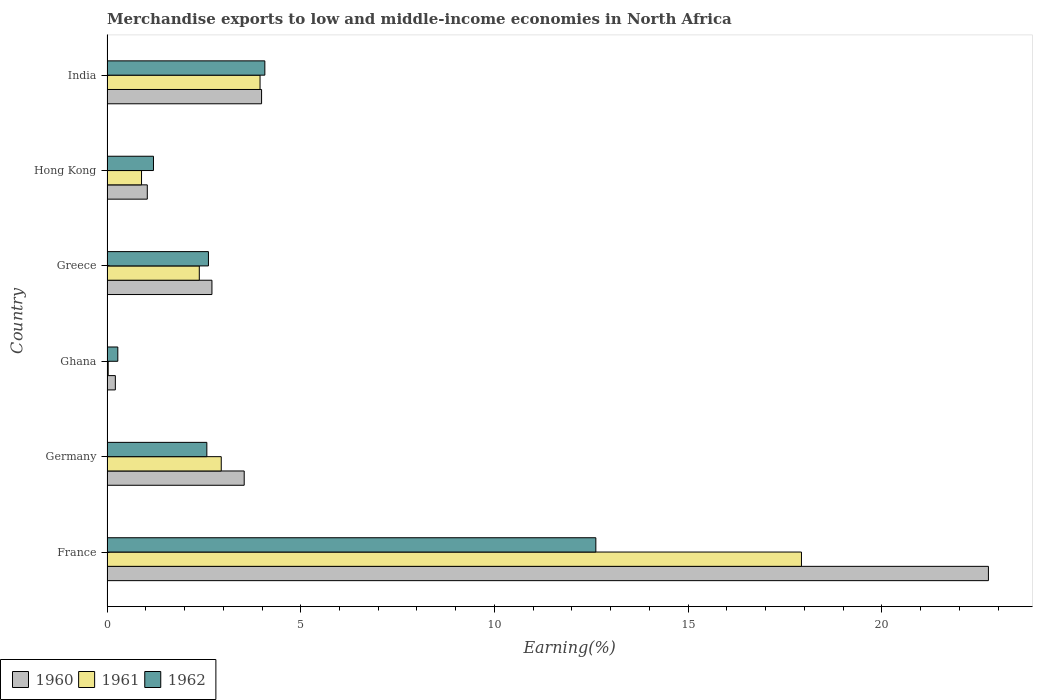How many different coloured bars are there?
Keep it short and to the point. 3. Are the number of bars on each tick of the Y-axis equal?
Your answer should be very brief. Yes. How many bars are there on the 1st tick from the top?
Give a very brief answer. 3. In how many cases, is the number of bars for a given country not equal to the number of legend labels?
Offer a very short reply. 0. What is the percentage of amount earned from merchandise exports in 1960 in Ghana?
Offer a very short reply. 0.22. Across all countries, what is the maximum percentage of amount earned from merchandise exports in 1962?
Ensure brevity in your answer.  12.62. Across all countries, what is the minimum percentage of amount earned from merchandise exports in 1960?
Provide a succinct answer. 0.22. What is the total percentage of amount earned from merchandise exports in 1960 in the graph?
Give a very brief answer. 34.24. What is the difference between the percentage of amount earned from merchandise exports in 1960 in France and that in Greece?
Keep it short and to the point. 20.04. What is the difference between the percentage of amount earned from merchandise exports in 1960 in Hong Kong and the percentage of amount earned from merchandise exports in 1962 in France?
Provide a succinct answer. -11.58. What is the average percentage of amount earned from merchandise exports in 1962 per country?
Your answer should be compact. 3.89. What is the difference between the percentage of amount earned from merchandise exports in 1961 and percentage of amount earned from merchandise exports in 1960 in France?
Give a very brief answer. -4.83. What is the ratio of the percentage of amount earned from merchandise exports in 1960 in Germany to that in Greece?
Keep it short and to the point. 1.31. Is the difference between the percentage of amount earned from merchandise exports in 1961 in France and Ghana greater than the difference between the percentage of amount earned from merchandise exports in 1960 in France and Ghana?
Make the answer very short. No. What is the difference between the highest and the second highest percentage of amount earned from merchandise exports in 1962?
Your response must be concise. 8.54. What is the difference between the highest and the lowest percentage of amount earned from merchandise exports in 1961?
Make the answer very short. 17.89. In how many countries, is the percentage of amount earned from merchandise exports in 1962 greater than the average percentage of amount earned from merchandise exports in 1962 taken over all countries?
Ensure brevity in your answer.  2. Is the sum of the percentage of amount earned from merchandise exports in 1960 in Germany and Ghana greater than the maximum percentage of amount earned from merchandise exports in 1961 across all countries?
Offer a very short reply. No. What does the 3rd bar from the bottom in Hong Kong represents?
Give a very brief answer. 1962. Is it the case that in every country, the sum of the percentage of amount earned from merchandise exports in 1961 and percentage of amount earned from merchandise exports in 1960 is greater than the percentage of amount earned from merchandise exports in 1962?
Provide a short and direct response. No. How many countries are there in the graph?
Your response must be concise. 6. What is the difference between two consecutive major ticks on the X-axis?
Your answer should be very brief. 5. Are the values on the major ticks of X-axis written in scientific E-notation?
Your answer should be compact. No. Where does the legend appear in the graph?
Keep it short and to the point. Bottom left. What is the title of the graph?
Make the answer very short. Merchandise exports to low and middle-income economies in North Africa. Does "2013" appear as one of the legend labels in the graph?
Make the answer very short. No. What is the label or title of the X-axis?
Keep it short and to the point. Earning(%). What is the label or title of the Y-axis?
Make the answer very short. Country. What is the Earning(%) of 1960 in France?
Make the answer very short. 22.75. What is the Earning(%) in 1961 in France?
Provide a succinct answer. 17.92. What is the Earning(%) in 1962 in France?
Offer a very short reply. 12.62. What is the Earning(%) of 1960 in Germany?
Offer a terse response. 3.54. What is the Earning(%) of 1961 in Germany?
Your response must be concise. 2.95. What is the Earning(%) of 1962 in Germany?
Offer a very short reply. 2.58. What is the Earning(%) of 1960 in Ghana?
Keep it short and to the point. 0.22. What is the Earning(%) in 1961 in Ghana?
Offer a terse response. 0.03. What is the Earning(%) of 1962 in Ghana?
Provide a succinct answer. 0.28. What is the Earning(%) of 1960 in Greece?
Give a very brief answer. 2.71. What is the Earning(%) of 1961 in Greece?
Your response must be concise. 2.38. What is the Earning(%) in 1962 in Greece?
Provide a short and direct response. 2.62. What is the Earning(%) of 1960 in Hong Kong?
Offer a terse response. 1.04. What is the Earning(%) in 1961 in Hong Kong?
Offer a very short reply. 0.89. What is the Earning(%) in 1962 in Hong Kong?
Offer a terse response. 1.2. What is the Earning(%) of 1960 in India?
Make the answer very short. 3.99. What is the Earning(%) of 1961 in India?
Offer a very short reply. 3.95. What is the Earning(%) in 1962 in India?
Keep it short and to the point. 4.07. Across all countries, what is the maximum Earning(%) in 1960?
Your response must be concise. 22.75. Across all countries, what is the maximum Earning(%) in 1961?
Provide a short and direct response. 17.92. Across all countries, what is the maximum Earning(%) in 1962?
Offer a terse response. 12.62. Across all countries, what is the minimum Earning(%) in 1960?
Give a very brief answer. 0.22. Across all countries, what is the minimum Earning(%) in 1961?
Ensure brevity in your answer.  0.03. Across all countries, what is the minimum Earning(%) in 1962?
Give a very brief answer. 0.28. What is the total Earning(%) in 1960 in the graph?
Make the answer very short. 34.24. What is the total Earning(%) of 1961 in the graph?
Provide a short and direct response. 28.12. What is the total Earning(%) of 1962 in the graph?
Your answer should be compact. 23.36. What is the difference between the Earning(%) of 1960 in France and that in Germany?
Your response must be concise. 19.21. What is the difference between the Earning(%) of 1961 in France and that in Germany?
Make the answer very short. 14.97. What is the difference between the Earning(%) of 1962 in France and that in Germany?
Offer a terse response. 10.04. What is the difference between the Earning(%) of 1960 in France and that in Ghana?
Give a very brief answer. 22.53. What is the difference between the Earning(%) of 1961 in France and that in Ghana?
Keep it short and to the point. 17.89. What is the difference between the Earning(%) of 1962 in France and that in Ghana?
Your answer should be compact. 12.34. What is the difference between the Earning(%) in 1960 in France and that in Greece?
Provide a succinct answer. 20.04. What is the difference between the Earning(%) of 1961 in France and that in Greece?
Keep it short and to the point. 15.54. What is the difference between the Earning(%) of 1962 in France and that in Greece?
Provide a succinct answer. 10. What is the difference between the Earning(%) in 1960 in France and that in Hong Kong?
Provide a short and direct response. 21.71. What is the difference between the Earning(%) of 1961 in France and that in Hong Kong?
Your answer should be very brief. 17.03. What is the difference between the Earning(%) of 1962 in France and that in Hong Kong?
Provide a succinct answer. 11.42. What is the difference between the Earning(%) of 1960 in France and that in India?
Your answer should be compact. 18.76. What is the difference between the Earning(%) in 1961 in France and that in India?
Your answer should be compact. 13.97. What is the difference between the Earning(%) of 1962 in France and that in India?
Provide a succinct answer. 8.54. What is the difference between the Earning(%) of 1960 in Germany and that in Ghana?
Keep it short and to the point. 3.33. What is the difference between the Earning(%) in 1961 in Germany and that in Ghana?
Offer a terse response. 2.92. What is the difference between the Earning(%) in 1962 in Germany and that in Ghana?
Keep it short and to the point. 2.3. What is the difference between the Earning(%) of 1960 in Germany and that in Greece?
Ensure brevity in your answer.  0.83. What is the difference between the Earning(%) in 1961 in Germany and that in Greece?
Your answer should be very brief. 0.57. What is the difference between the Earning(%) of 1962 in Germany and that in Greece?
Make the answer very short. -0.04. What is the difference between the Earning(%) in 1960 in Germany and that in Hong Kong?
Your response must be concise. 2.5. What is the difference between the Earning(%) of 1961 in Germany and that in Hong Kong?
Your answer should be very brief. 2.06. What is the difference between the Earning(%) of 1962 in Germany and that in Hong Kong?
Provide a succinct answer. 1.38. What is the difference between the Earning(%) in 1960 in Germany and that in India?
Offer a very short reply. -0.45. What is the difference between the Earning(%) in 1961 in Germany and that in India?
Your response must be concise. -1. What is the difference between the Earning(%) of 1962 in Germany and that in India?
Provide a succinct answer. -1.5. What is the difference between the Earning(%) of 1960 in Ghana and that in Greece?
Ensure brevity in your answer.  -2.49. What is the difference between the Earning(%) in 1961 in Ghana and that in Greece?
Offer a terse response. -2.35. What is the difference between the Earning(%) of 1962 in Ghana and that in Greece?
Your response must be concise. -2.34. What is the difference between the Earning(%) of 1960 in Ghana and that in Hong Kong?
Provide a succinct answer. -0.82. What is the difference between the Earning(%) in 1961 in Ghana and that in Hong Kong?
Provide a short and direct response. -0.86. What is the difference between the Earning(%) in 1962 in Ghana and that in Hong Kong?
Offer a very short reply. -0.92. What is the difference between the Earning(%) of 1960 in Ghana and that in India?
Offer a terse response. -3.77. What is the difference between the Earning(%) in 1961 in Ghana and that in India?
Your answer should be very brief. -3.92. What is the difference between the Earning(%) of 1962 in Ghana and that in India?
Your answer should be very brief. -3.79. What is the difference between the Earning(%) in 1960 in Greece and that in Hong Kong?
Ensure brevity in your answer.  1.67. What is the difference between the Earning(%) of 1961 in Greece and that in Hong Kong?
Ensure brevity in your answer.  1.49. What is the difference between the Earning(%) of 1962 in Greece and that in Hong Kong?
Offer a very short reply. 1.42. What is the difference between the Earning(%) in 1960 in Greece and that in India?
Offer a terse response. -1.28. What is the difference between the Earning(%) in 1961 in Greece and that in India?
Make the answer very short. -1.57. What is the difference between the Earning(%) in 1962 in Greece and that in India?
Keep it short and to the point. -1.46. What is the difference between the Earning(%) in 1960 in Hong Kong and that in India?
Your answer should be compact. -2.95. What is the difference between the Earning(%) of 1961 in Hong Kong and that in India?
Your response must be concise. -3.06. What is the difference between the Earning(%) in 1962 in Hong Kong and that in India?
Keep it short and to the point. -2.87. What is the difference between the Earning(%) of 1960 in France and the Earning(%) of 1961 in Germany?
Make the answer very short. 19.8. What is the difference between the Earning(%) of 1960 in France and the Earning(%) of 1962 in Germany?
Your answer should be very brief. 20.17. What is the difference between the Earning(%) in 1961 in France and the Earning(%) in 1962 in Germany?
Offer a very short reply. 15.35. What is the difference between the Earning(%) of 1960 in France and the Earning(%) of 1961 in Ghana?
Offer a very short reply. 22.72. What is the difference between the Earning(%) in 1960 in France and the Earning(%) in 1962 in Ghana?
Provide a short and direct response. 22.47. What is the difference between the Earning(%) of 1961 in France and the Earning(%) of 1962 in Ghana?
Your answer should be compact. 17.64. What is the difference between the Earning(%) of 1960 in France and the Earning(%) of 1961 in Greece?
Your response must be concise. 20.37. What is the difference between the Earning(%) of 1960 in France and the Earning(%) of 1962 in Greece?
Keep it short and to the point. 20.13. What is the difference between the Earning(%) of 1961 in France and the Earning(%) of 1962 in Greece?
Provide a succinct answer. 15.3. What is the difference between the Earning(%) of 1960 in France and the Earning(%) of 1961 in Hong Kong?
Offer a terse response. 21.86. What is the difference between the Earning(%) in 1960 in France and the Earning(%) in 1962 in Hong Kong?
Provide a succinct answer. 21.55. What is the difference between the Earning(%) of 1961 in France and the Earning(%) of 1962 in Hong Kong?
Your answer should be compact. 16.72. What is the difference between the Earning(%) in 1960 in France and the Earning(%) in 1961 in India?
Provide a succinct answer. 18.8. What is the difference between the Earning(%) of 1960 in France and the Earning(%) of 1962 in India?
Offer a very short reply. 18.67. What is the difference between the Earning(%) of 1961 in France and the Earning(%) of 1962 in India?
Offer a very short reply. 13.85. What is the difference between the Earning(%) in 1960 in Germany and the Earning(%) in 1961 in Ghana?
Make the answer very short. 3.51. What is the difference between the Earning(%) in 1960 in Germany and the Earning(%) in 1962 in Ghana?
Give a very brief answer. 3.26. What is the difference between the Earning(%) of 1961 in Germany and the Earning(%) of 1962 in Ghana?
Your response must be concise. 2.67. What is the difference between the Earning(%) in 1960 in Germany and the Earning(%) in 1961 in Greece?
Provide a short and direct response. 1.16. What is the difference between the Earning(%) in 1960 in Germany and the Earning(%) in 1962 in Greece?
Offer a very short reply. 0.92. What is the difference between the Earning(%) in 1961 in Germany and the Earning(%) in 1962 in Greece?
Keep it short and to the point. 0.33. What is the difference between the Earning(%) in 1960 in Germany and the Earning(%) in 1961 in Hong Kong?
Your answer should be compact. 2.65. What is the difference between the Earning(%) in 1960 in Germany and the Earning(%) in 1962 in Hong Kong?
Your response must be concise. 2.34. What is the difference between the Earning(%) in 1961 in Germany and the Earning(%) in 1962 in Hong Kong?
Provide a succinct answer. 1.75. What is the difference between the Earning(%) in 1960 in Germany and the Earning(%) in 1961 in India?
Your response must be concise. -0.41. What is the difference between the Earning(%) in 1960 in Germany and the Earning(%) in 1962 in India?
Your answer should be compact. -0.53. What is the difference between the Earning(%) of 1961 in Germany and the Earning(%) of 1962 in India?
Provide a short and direct response. -1.12. What is the difference between the Earning(%) of 1960 in Ghana and the Earning(%) of 1961 in Greece?
Make the answer very short. -2.17. What is the difference between the Earning(%) in 1960 in Ghana and the Earning(%) in 1962 in Greece?
Provide a succinct answer. -2.4. What is the difference between the Earning(%) in 1961 in Ghana and the Earning(%) in 1962 in Greece?
Offer a terse response. -2.59. What is the difference between the Earning(%) of 1960 in Ghana and the Earning(%) of 1961 in Hong Kong?
Ensure brevity in your answer.  -0.68. What is the difference between the Earning(%) in 1960 in Ghana and the Earning(%) in 1962 in Hong Kong?
Offer a very short reply. -0.98. What is the difference between the Earning(%) in 1961 in Ghana and the Earning(%) in 1962 in Hong Kong?
Offer a very short reply. -1.17. What is the difference between the Earning(%) in 1960 in Ghana and the Earning(%) in 1961 in India?
Offer a very short reply. -3.73. What is the difference between the Earning(%) of 1960 in Ghana and the Earning(%) of 1962 in India?
Your response must be concise. -3.86. What is the difference between the Earning(%) of 1961 in Ghana and the Earning(%) of 1962 in India?
Your response must be concise. -4.04. What is the difference between the Earning(%) of 1960 in Greece and the Earning(%) of 1961 in Hong Kong?
Your answer should be very brief. 1.82. What is the difference between the Earning(%) in 1960 in Greece and the Earning(%) in 1962 in Hong Kong?
Keep it short and to the point. 1.51. What is the difference between the Earning(%) in 1961 in Greece and the Earning(%) in 1962 in Hong Kong?
Your response must be concise. 1.18. What is the difference between the Earning(%) in 1960 in Greece and the Earning(%) in 1961 in India?
Your response must be concise. -1.24. What is the difference between the Earning(%) of 1960 in Greece and the Earning(%) of 1962 in India?
Provide a short and direct response. -1.37. What is the difference between the Earning(%) of 1961 in Greece and the Earning(%) of 1962 in India?
Make the answer very short. -1.69. What is the difference between the Earning(%) of 1960 in Hong Kong and the Earning(%) of 1961 in India?
Offer a terse response. -2.91. What is the difference between the Earning(%) of 1960 in Hong Kong and the Earning(%) of 1962 in India?
Make the answer very short. -3.03. What is the difference between the Earning(%) in 1961 in Hong Kong and the Earning(%) in 1962 in India?
Your response must be concise. -3.18. What is the average Earning(%) of 1960 per country?
Your response must be concise. 5.71. What is the average Earning(%) in 1961 per country?
Your response must be concise. 4.69. What is the average Earning(%) in 1962 per country?
Your answer should be compact. 3.89. What is the difference between the Earning(%) in 1960 and Earning(%) in 1961 in France?
Ensure brevity in your answer.  4.83. What is the difference between the Earning(%) in 1960 and Earning(%) in 1962 in France?
Offer a very short reply. 10.13. What is the difference between the Earning(%) of 1961 and Earning(%) of 1962 in France?
Provide a succinct answer. 5.31. What is the difference between the Earning(%) of 1960 and Earning(%) of 1961 in Germany?
Your answer should be very brief. 0.59. What is the difference between the Earning(%) of 1960 and Earning(%) of 1962 in Germany?
Your answer should be very brief. 0.96. What is the difference between the Earning(%) in 1961 and Earning(%) in 1962 in Germany?
Your answer should be compact. 0.37. What is the difference between the Earning(%) of 1960 and Earning(%) of 1961 in Ghana?
Give a very brief answer. 0.18. What is the difference between the Earning(%) in 1960 and Earning(%) in 1962 in Ghana?
Your response must be concise. -0.06. What is the difference between the Earning(%) in 1961 and Earning(%) in 1962 in Ghana?
Make the answer very short. -0.25. What is the difference between the Earning(%) in 1960 and Earning(%) in 1961 in Greece?
Your response must be concise. 0.33. What is the difference between the Earning(%) of 1960 and Earning(%) of 1962 in Greece?
Provide a short and direct response. 0.09. What is the difference between the Earning(%) of 1961 and Earning(%) of 1962 in Greece?
Keep it short and to the point. -0.24. What is the difference between the Earning(%) of 1960 and Earning(%) of 1961 in Hong Kong?
Your answer should be compact. 0.15. What is the difference between the Earning(%) in 1960 and Earning(%) in 1962 in Hong Kong?
Offer a very short reply. -0.16. What is the difference between the Earning(%) in 1961 and Earning(%) in 1962 in Hong Kong?
Your answer should be compact. -0.31. What is the difference between the Earning(%) of 1960 and Earning(%) of 1961 in India?
Offer a terse response. 0.04. What is the difference between the Earning(%) in 1960 and Earning(%) in 1962 in India?
Ensure brevity in your answer.  -0.08. What is the difference between the Earning(%) in 1961 and Earning(%) in 1962 in India?
Provide a succinct answer. -0.12. What is the ratio of the Earning(%) of 1960 in France to that in Germany?
Your answer should be very brief. 6.42. What is the ratio of the Earning(%) of 1961 in France to that in Germany?
Your answer should be very brief. 6.08. What is the ratio of the Earning(%) in 1962 in France to that in Germany?
Your answer should be compact. 4.9. What is the ratio of the Earning(%) in 1960 in France to that in Ghana?
Offer a terse response. 105.68. What is the ratio of the Earning(%) in 1961 in France to that in Ghana?
Offer a very short reply. 577.63. What is the ratio of the Earning(%) in 1962 in France to that in Ghana?
Make the answer very short. 45.22. What is the ratio of the Earning(%) in 1961 in France to that in Greece?
Provide a succinct answer. 7.52. What is the ratio of the Earning(%) of 1962 in France to that in Greece?
Offer a terse response. 4.82. What is the ratio of the Earning(%) in 1960 in France to that in Hong Kong?
Offer a terse response. 21.88. What is the ratio of the Earning(%) of 1961 in France to that in Hong Kong?
Your answer should be very brief. 20.12. What is the ratio of the Earning(%) in 1962 in France to that in Hong Kong?
Offer a very short reply. 10.52. What is the ratio of the Earning(%) in 1960 in France to that in India?
Give a very brief answer. 5.7. What is the ratio of the Earning(%) in 1961 in France to that in India?
Offer a very short reply. 4.54. What is the ratio of the Earning(%) in 1962 in France to that in India?
Keep it short and to the point. 3.1. What is the ratio of the Earning(%) of 1960 in Germany to that in Ghana?
Keep it short and to the point. 16.45. What is the ratio of the Earning(%) of 1961 in Germany to that in Ghana?
Provide a short and direct response. 95.03. What is the ratio of the Earning(%) of 1962 in Germany to that in Ghana?
Your response must be concise. 9.24. What is the ratio of the Earning(%) in 1960 in Germany to that in Greece?
Give a very brief answer. 1.31. What is the ratio of the Earning(%) of 1961 in Germany to that in Greece?
Ensure brevity in your answer.  1.24. What is the ratio of the Earning(%) of 1962 in Germany to that in Greece?
Make the answer very short. 0.98. What is the ratio of the Earning(%) of 1960 in Germany to that in Hong Kong?
Provide a short and direct response. 3.41. What is the ratio of the Earning(%) in 1961 in Germany to that in Hong Kong?
Your response must be concise. 3.31. What is the ratio of the Earning(%) in 1962 in Germany to that in Hong Kong?
Make the answer very short. 2.15. What is the ratio of the Earning(%) of 1960 in Germany to that in India?
Keep it short and to the point. 0.89. What is the ratio of the Earning(%) of 1961 in Germany to that in India?
Provide a short and direct response. 0.75. What is the ratio of the Earning(%) of 1962 in Germany to that in India?
Your answer should be compact. 0.63. What is the ratio of the Earning(%) of 1960 in Ghana to that in Greece?
Offer a very short reply. 0.08. What is the ratio of the Earning(%) of 1961 in Ghana to that in Greece?
Offer a terse response. 0.01. What is the ratio of the Earning(%) in 1962 in Ghana to that in Greece?
Your answer should be compact. 0.11. What is the ratio of the Earning(%) of 1960 in Ghana to that in Hong Kong?
Your response must be concise. 0.21. What is the ratio of the Earning(%) in 1961 in Ghana to that in Hong Kong?
Your answer should be very brief. 0.03. What is the ratio of the Earning(%) in 1962 in Ghana to that in Hong Kong?
Offer a very short reply. 0.23. What is the ratio of the Earning(%) of 1960 in Ghana to that in India?
Your response must be concise. 0.05. What is the ratio of the Earning(%) in 1961 in Ghana to that in India?
Offer a terse response. 0.01. What is the ratio of the Earning(%) in 1962 in Ghana to that in India?
Provide a succinct answer. 0.07. What is the ratio of the Earning(%) of 1960 in Greece to that in Hong Kong?
Provide a short and direct response. 2.6. What is the ratio of the Earning(%) in 1961 in Greece to that in Hong Kong?
Your response must be concise. 2.67. What is the ratio of the Earning(%) of 1962 in Greece to that in Hong Kong?
Your answer should be compact. 2.18. What is the ratio of the Earning(%) of 1960 in Greece to that in India?
Your answer should be compact. 0.68. What is the ratio of the Earning(%) in 1961 in Greece to that in India?
Give a very brief answer. 0.6. What is the ratio of the Earning(%) in 1962 in Greece to that in India?
Your answer should be very brief. 0.64. What is the ratio of the Earning(%) in 1960 in Hong Kong to that in India?
Provide a succinct answer. 0.26. What is the ratio of the Earning(%) in 1961 in Hong Kong to that in India?
Provide a succinct answer. 0.23. What is the ratio of the Earning(%) of 1962 in Hong Kong to that in India?
Your answer should be compact. 0.29. What is the difference between the highest and the second highest Earning(%) of 1960?
Offer a very short reply. 18.76. What is the difference between the highest and the second highest Earning(%) of 1961?
Provide a short and direct response. 13.97. What is the difference between the highest and the second highest Earning(%) of 1962?
Ensure brevity in your answer.  8.54. What is the difference between the highest and the lowest Earning(%) of 1960?
Make the answer very short. 22.53. What is the difference between the highest and the lowest Earning(%) in 1961?
Make the answer very short. 17.89. What is the difference between the highest and the lowest Earning(%) in 1962?
Your answer should be very brief. 12.34. 